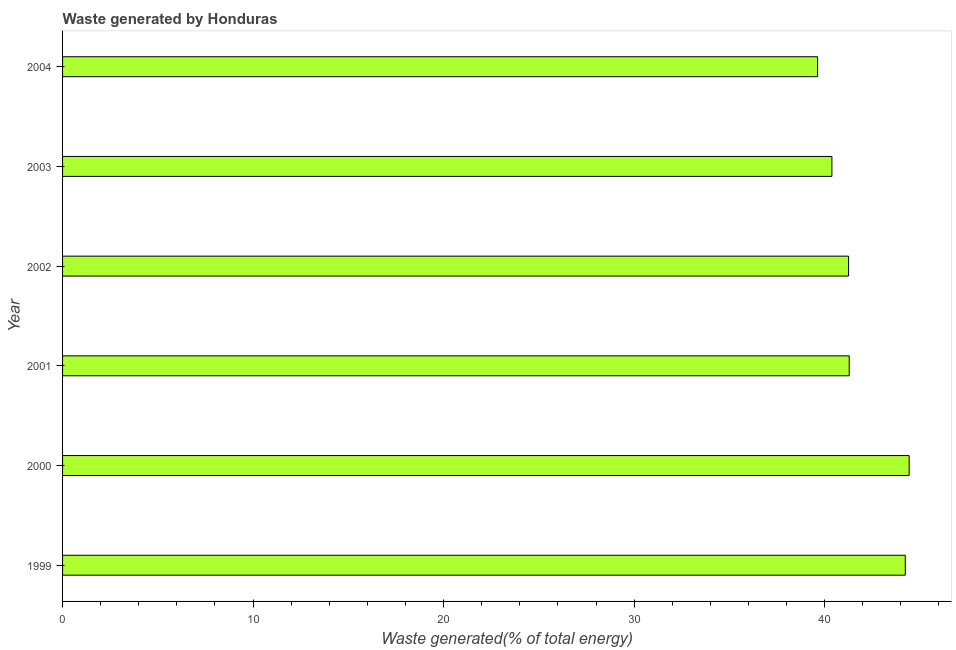Does the graph contain grids?
Provide a short and direct response. No. What is the title of the graph?
Provide a succinct answer. Waste generated by Honduras. What is the label or title of the X-axis?
Your answer should be very brief. Waste generated(% of total energy). What is the label or title of the Y-axis?
Your response must be concise. Year. What is the amount of waste generated in 2002?
Your answer should be very brief. 41.26. Across all years, what is the maximum amount of waste generated?
Provide a short and direct response. 44.44. Across all years, what is the minimum amount of waste generated?
Make the answer very short. 39.63. In which year was the amount of waste generated minimum?
Give a very brief answer. 2004. What is the sum of the amount of waste generated?
Give a very brief answer. 251.23. What is the difference between the amount of waste generated in 2002 and 2004?
Your answer should be very brief. 1.62. What is the average amount of waste generated per year?
Provide a short and direct response. 41.87. What is the median amount of waste generated?
Your response must be concise. 41.27. In how many years, is the amount of waste generated greater than 36 %?
Your answer should be compact. 6. Do a majority of the years between 1999 and 2004 (inclusive) have amount of waste generated greater than 30 %?
Keep it short and to the point. Yes. What is the ratio of the amount of waste generated in 1999 to that in 2003?
Your response must be concise. 1.09. Is the difference between the amount of waste generated in 2000 and 2004 greater than the difference between any two years?
Give a very brief answer. Yes. What is the difference between the highest and the second highest amount of waste generated?
Keep it short and to the point. 0.2. Is the sum of the amount of waste generated in 2001 and 2004 greater than the maximum amount of waste generated across all years?
Give a very brief answer. Yes. What is the difference between the highest and the lowest amount of waste generated?
Ensure brevity in your answer.  4.81. In how many years, is the amount of waste generated greater than the average amount of waste generated taken over all years?
Your answer should be compact. 2. Are all the bars in the graph horizontal?
Make the answer very short. Yes. Are the values on the major ticks of X-axis written in scientific E-notation?
Keep it short and to the point. No. What is the Waste generated(% of total energy) in 1999?
Provide a succinct answer. 44.23. What is the Waste generated(% of total energy) in 2000?
Provide a short and direct response. 44.44. What is the Waste generated(% of total energy) of 2001?
Ensure brevity in your answer.  41.29. What is the Waste generated(% of total energy) of 2002?
Provide a short and direct response. 41.26. What is the Waste generated(% of total energy) in 2003?
Your response must be concise. 40.38. What is the Waste generated(% of total energy) in 2004?
Offer a very short reply. 39.63. What is the difference between the Waste generated(% of total energy) in 1999 and 2000?
Your answer should be very brief. -0.2. What is the difference between the Waste generated(% of total energy) in 1999 and 2001?
Offer a terse response. 2.94. What is the difference between the Waste generated(% of total energy) in 1999 and 2002?
Provide a short and direct response. 2.98. What is the difference between the Waste generated(% of total energy) in 1999 and 2003?
Give a very brief answer. 3.85. What is the difference between the Waste generated(% of total energy) in 1999 and 2004?
Offer a very short reply. 4.6. What is the difference between the Waste generated(% of total energy) in 2000 and 2001?
Provide a short and direct response. 3.15. What is the difference between the Waste generated(% of total energy) in 2000 and 2002?
Offer a terse response. 3.18. What is the difference between the Waste generated(% of total energy) in 2000 and 2003?
Provide a succinct answer. 4.05. What is the difference between the Waste generated(% of total energy) in 2000 and 2004?
Provide a short and direct response. 4.81. What is the difference between the Waste generated(% of total energy) in 2001 and 2002?
Keep it short and to the point. 0.03. What is the difference between the Waste generated(% of total energy) in 2001 and 2003?
Offer a terse response. 0.91. What is the difference between the Waste generated(% of total energy) in 2001 and 2004?
Your response must be concise. 1.66. What is the difference between the Waste generated(% of total energy) in 2002 and 2003?
Your response must be concise. 0.87. What is the difference between the Waste generated(% of total energy) in 2002 and 2004?
Make the answer very short. 1.63. What is the difference between the Waste generated(% of total energy) in 2003 and 2004?
Keep it short and to the point. 0.75. What is the ratio of the Waste generated(% of total energy) in 1999 to that in 2001?
Your response must be concise. 1.07. What is the ratio of the Waste generated(% of total energy) in 1999 to that in 2002?
Give a very brief answer. 1.07. What is the ratio of the Waste generated(% of total energy) in 1999 to that in 2003?
Give a very brief answer. 1.09. What is the ratio of the Waste generated(% of total energy) in 1999 to that in 2004?
Provide a succinct answer. 1.12. What is the ratio of the Waste generated(% of total energy) in 2000 to that in 2001?
Your answer should be very brief. 1.08. What is the ratio of the Waste generated(% of total energy) in 2000 to that in 2002?
Offer a terse response. 1.08. What is the ratio of the Waste generated(% of total energy) in 2000 to that in 2004?
Provide a succinct answer. 1.12. What is the ratio of the Waste generated(% of total energy) in 2001 to that in 2002?
Your response must be concise. 1. What is the ratio of the Waste generated(% of total energy) in 2001 to that in 2003?
Ensure brevity in your answer.  1.02. What is the ratio of the Waste generated(% of total energy) in 2001 to that in 2004?
Give a very brief answer. 1.04. What is the ratio of the Waste generated(% of total energy) in 2002 to that in 2003?
Your answer should be compact. 1.02. What is the ratio of the Waste generated(% of total energy) in 2002 to that in 2004?
Your response must be concise. 1.04. What is the ratio of the Waste generated(% of total energy) in 2003 to that in 2004?
Ensure brevity in your answer.  1.02. 